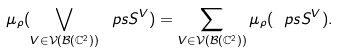<formula> <loc_0><loc_0><loc_500><loc_500>\mu _ { \rho } ( \bigvee _ { V \in \mathcal { V } ( \mathcal { B } ( \mathbb { C } ^ { 2 } ) ) } \ p s S ^ { V } ) = \sum _ { V \in \mathcal { V } ( \mathcal { B } ( \mathbb { C } ^ { 2 } ) ) } \mu _ { \rho } ( \ p s S ^ { V } ) .</formula> 